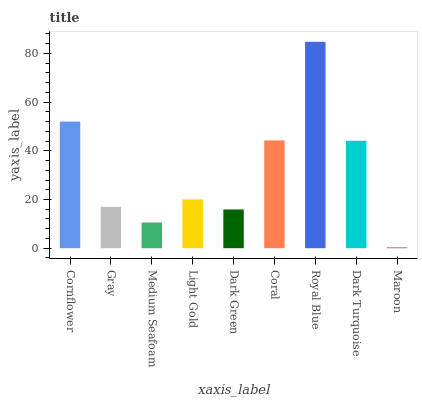Is Maroon the minimum?
Answer yes or no. Yes. Is Royal Blue the maximum?
Answer yes or no. Yes. Is Gray the minimum?
Answer yes or no. No. Is Gray the maximum?
Answer yes or no. No. Is Cornflower greater than Gray?
Answer yes or no. Yes. Is Gray less than Cornflower?
Answer yes or no. Yes. Is Gray greater than Cornflower?
Answer yes or no. No. Is Cornflower less than Gray?
Answer yes or no. No. Is Light Gold the high median?
Answer yes or no. Yes. Is Light Gold the low median?
Answer yes or no. Yes. Is Dark Turquoise the high median?
Answer yes or no. No. Is Gray the low median?
Answer yes or no. No. 